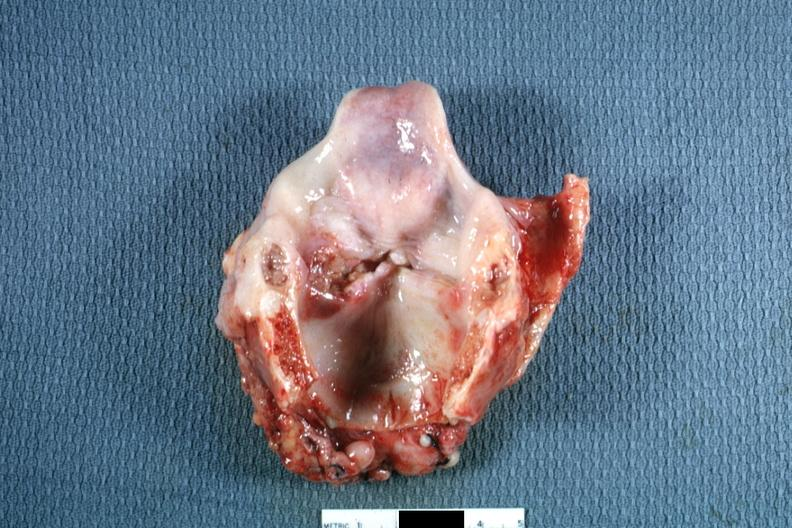s larynx present?
Answer the question using a single word or phrase. Yes 